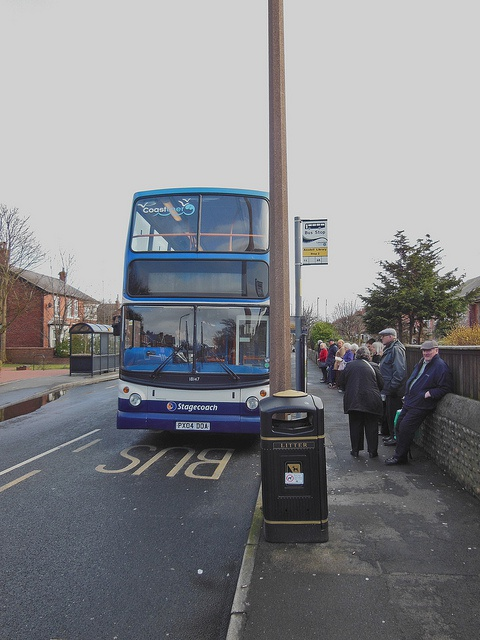Describe the objects in this image and their specific colors. I can see bus in lightgray, gray, black, and navy tones, people in lightgray, black, navy, gray, and darkgray tones, people in lightgray, black, gray, and darkgray tones, people in lightgray, black, gray, and darkgray tones, and people in lightgray, black, gray, and purple tones in this image. 